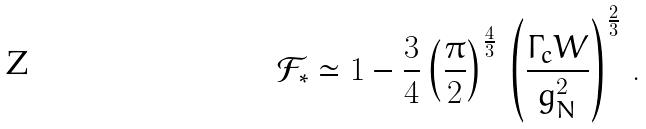Convert formula to latex. <formula><loc_0><loc_0><loc_500><loc_500>\mathcal { F } _ { * } \simeq 1 - \frac { 3 } { 4 } \left ( \frac { \pi } { 2 } \right ) ^ { \frac { 4 } { 3 } } \, \left ( \frac { \Gamma _ { c } W } { g _ { N } ^ { 2 } } \right ) ^ { \frac { 2 } { 3 } } \, .</formula> 